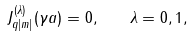<formula> <loc_0><loc_0><loc_500><loc_500>J _ { q | m | } ^ { ( \lambda ) } ( \gamma a ) = 0 , \quad \lambda = 0 , 1 ,</formula> 